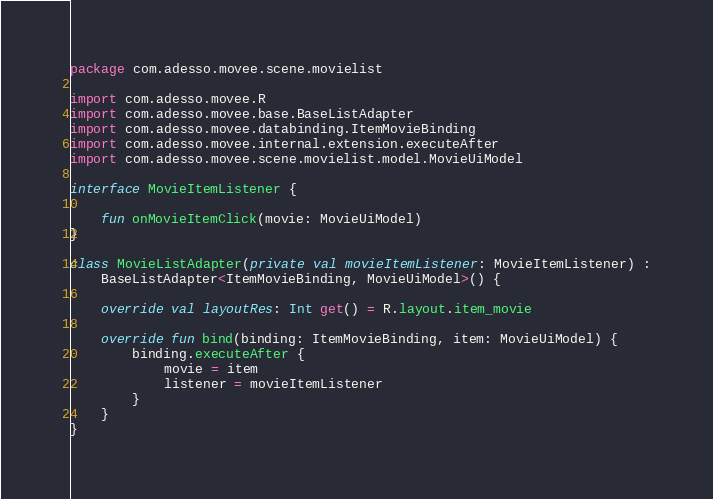Convert code to text. <code><loc_0><loc_0><loc_500><loc_500><_Kotlin_>package com.adesso.movee.scene.movielist

import com.adesso.movee.R
import com.adesso.movee.base.BaseListAdapter
import com.adesso.movee.databinding.ItemMovieBinding
import com.adesso.movee.internal.extension.executeAfter
import com.adesso.movee.scene.movielist.model.MovieUiModel

interface MovieItemListener {

    fun onMovieItemClick(movie: MovieUiModel)
}

class MovieListAdapter(private val movieItemListener: MovieItemListener) :
    BaseListAdapter<ItemMovieBinding, MovieUiModel>() {

    override val layoutRes: Int get() = R.layout.item_movie

    override fun bind(binding: ItemMovieBinding, item: MovieUiModel) {
        binding.executeAfter {
            movie = item
            listener = movieItemListener
        }
    }
}
</code> 